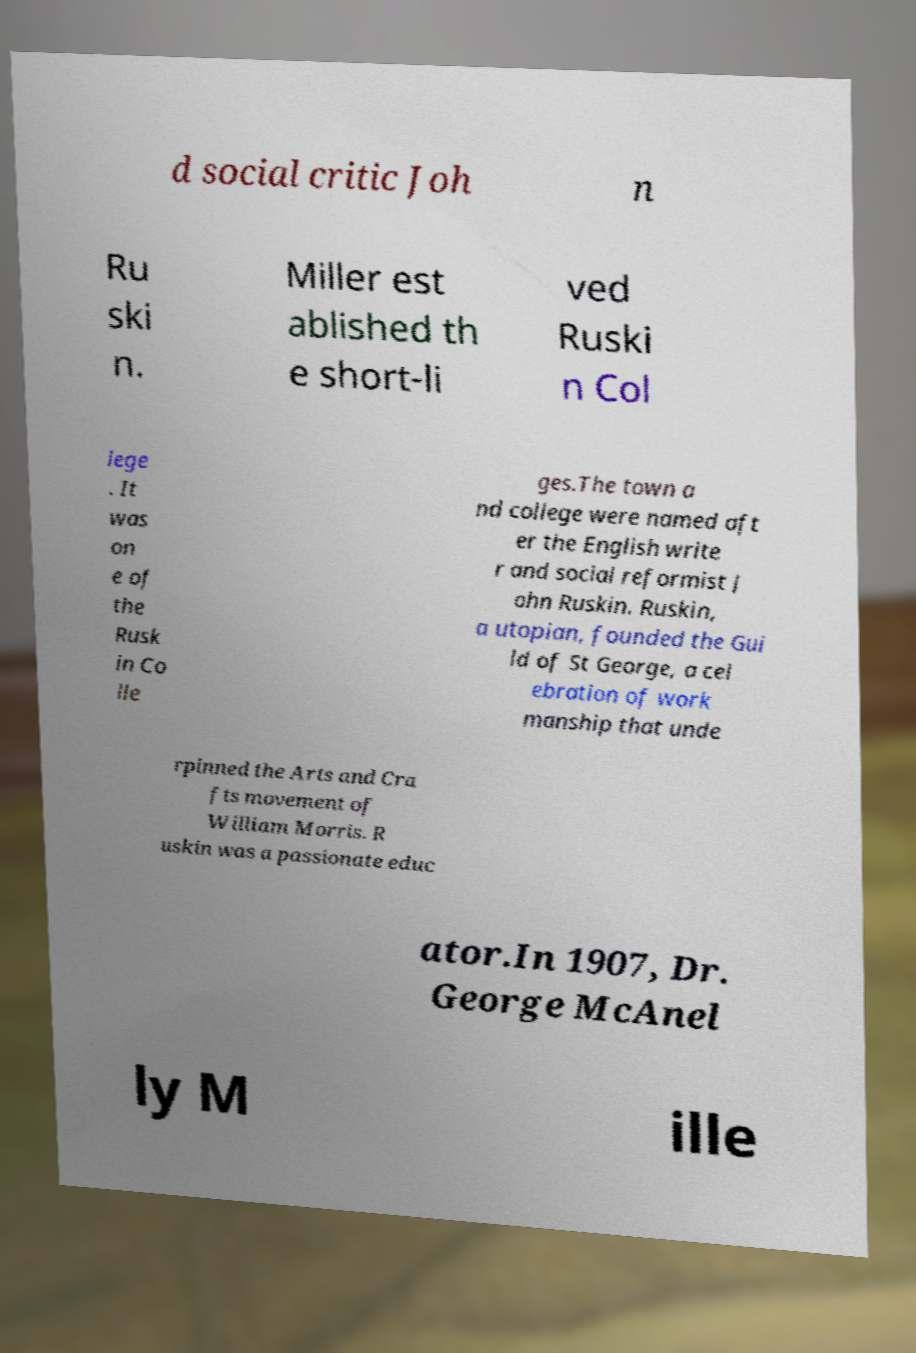Please read and relay the text visible in this image. What does it say? d social critic Joh n Ru ski n. Miller est ablished th e short-li ved Ruski n Col lege . It was on e of the Rusk in Co lle ges.The town a nd college were named aft er the English write r and social reformist J ohn Ruskin. Ruskin, a utopian, founded the Gui ld of St George, a cel ebration of work manship that unde rpinned the Arts and Cra fts movement of William Morris. R uskin was a passionate educ ator.In 1907, Dr. George McAnel ly M ille 